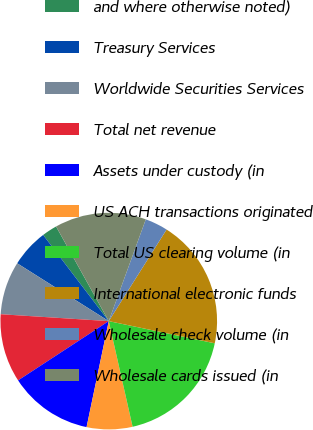Convert chart to OTSL. <chart><loc_0><loc_0><loc_500><loc_500><pie_chart><fcel>and where otherwise noted)<fcel>Treasury Services<fcel>Worldwide Securities Services<fcel>Total net revenue<fcel>Assets under custody (in<fcel>US ACH transactions originated<fcel>Total US clearing volume (in<fcel>International electronic funds<fcel>Wholesale check volume (in<fcel>Wholesale cards issued (in<nl><fcel>2.27%<fcel>5.68%<fcel>7.95%<fcel>10.23%<fcel>12.5%<fcel>6.82%<fcel>18.18%<fcel>19.32%<fcel>3.41%<fcel>13.64%<nl></chart> 